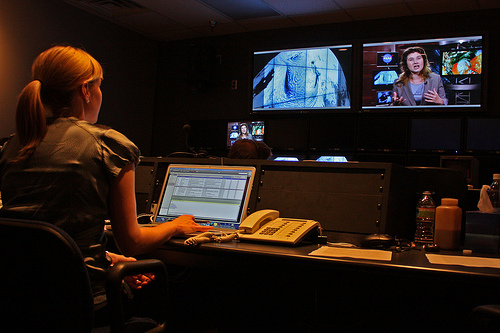What types of content are being shown on the screens? There are multiple types of content displayed across the screens, including what appears to be a news broadcast and a close-up of animal imagery, which may suggest that the work being done relates to a diverse range of subjects, possibly for a broadcast segment or a documentary. 